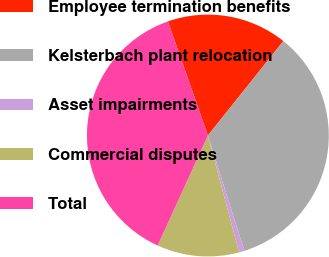<chart> <loc_0><loc_0><loc_500><loc_500><pie_chart><fcel>Employee termination benefits<fcel>Kelsterbach plant relocation<fcel>Asset impairments<fcel>Commercial disputes<fcel>Total<nl><fcel>16.09%<fcel>34.38%<fcel>0.73%<fcel>10.97%<fcel>37.82%<nl></chart> 